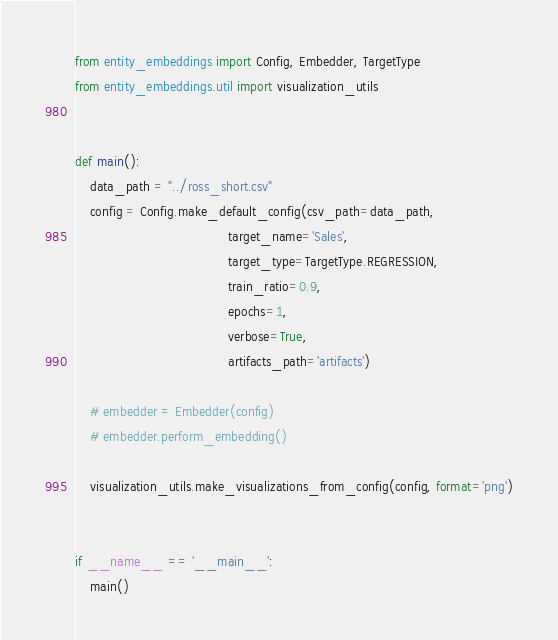Convert code to text. <code><loc_0><loc_0><loc_500><loc_500><_Python_>from entity_embeddings import Config, Embedder, TargetType
from entity_embeddings.util import visualization_utils


def main():
    data_path = "../ross_short.csv"
    config = Config.make_default_config(csv_path=data_path,
                                        target_name='Sales',
                                        target_type=TargetType.REGRESSION,
                                        train_ratio=0.9,
                                        epochs=1,
                                        verbose=True,
                                        artifacts_path='artifacts')

    # embedder = Embedder(config)
    # embedder.perform_embedding()

    visualization_utils.make_visualizations_from_config(config, format='png')


if __name__ == '__main__':
    main()
</code> 